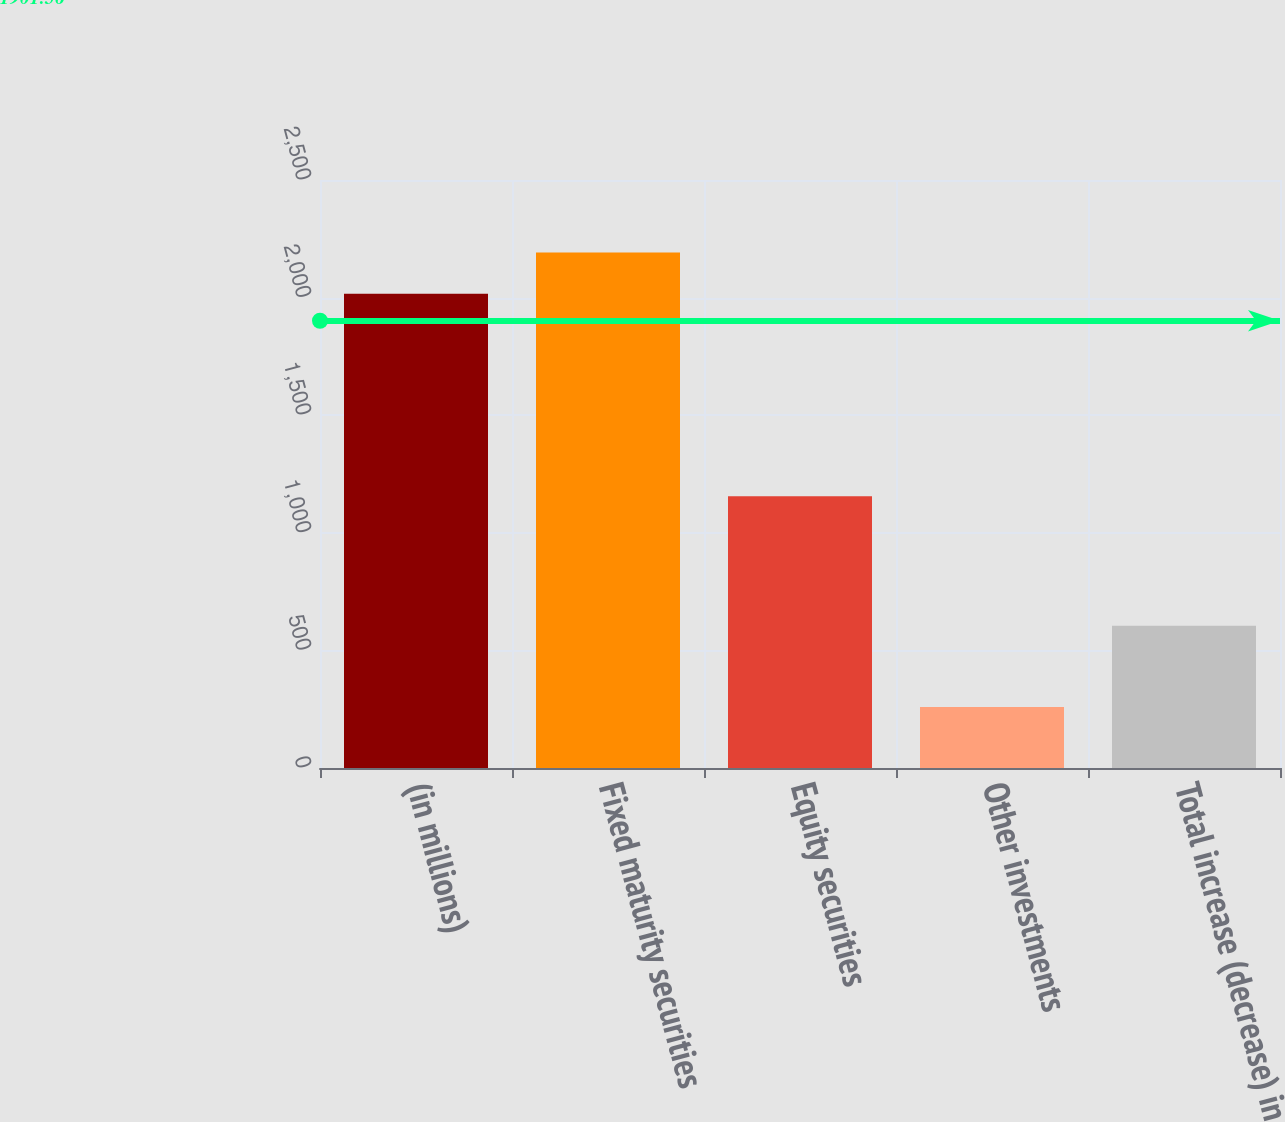<chart> <loc_0><loc_0><loc_500><loc_500><bar_chart><fcel>(in millions)<fcel>Fixed maturity securities<fcel>Equity securities<fcel>Other investments<fcel>Total increase (decrease) in<nl><fcel>2016<fcel>2192<fcel>1155<fcel>259<fcel>605<nl></chart> 